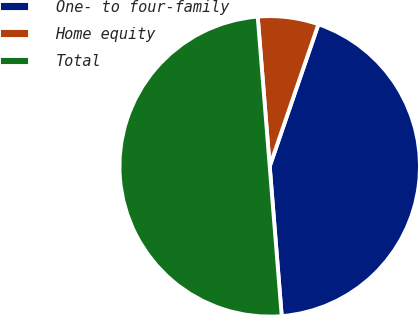<chart> <loc_0><loc_0><loc_500><loc_500><pie_chart><fcel>One- to four-family<fcel>Home equity<fcel>Total<nl><fcel>43.47%<fcel>6.53%<fcel>50.0%<nl></chart> 